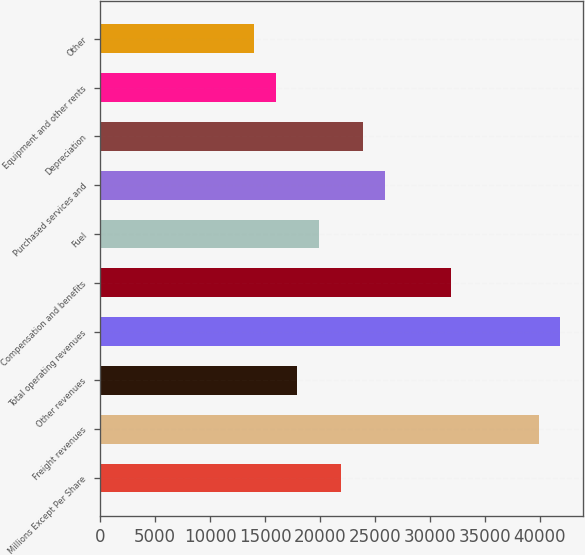Convert chart. <chart><loc_0><loc_0><loc_500><loc_500><bar_chart><fcel>Millions Except Per Share<fcel>Freight revenues<fcel>Other revenues<fcel>Total operating revenues<fcel>Compensation and benefits<fcel>Fuel<fcel>Purchased services and<fcel>Depreciation<fcel>Equipment and other rents<fcel>Other<nl><fcel>21934.8<fcel>39879.7<fcel>17947.1<fcel>41873.6<fcel>31904.2<fcel>19941<fcel>25922.6<fcel>23928.7<fcel>15953.2<fcel>13959.4<nl></chart> 